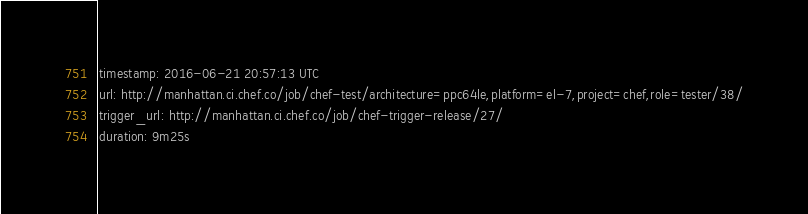Convert code to text. <code><loc_0><loc_0><loc_500><loc_500><_YAML_>timestamp: 2016-06-21 20:57:13 UTC
url: http://manhattan.ci.chef.co/job/chef-test/architecture=ppc64le,platform=el-7,project=chef,role=tester/38/
trigger_url: http://manhattan.ci.chef.co/job/chef-trigger-release/27/
duration: 9m25s
</code> 